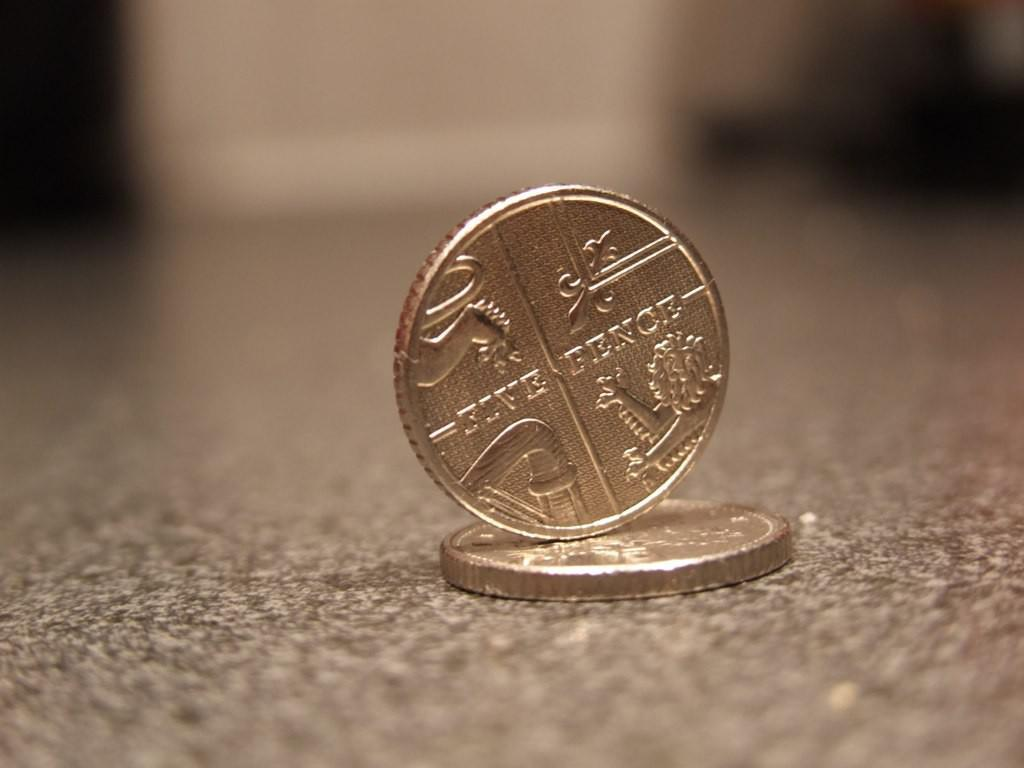<image>
Provide a brief description of the given image. Five Pence is displayed on the coin balancing on another 